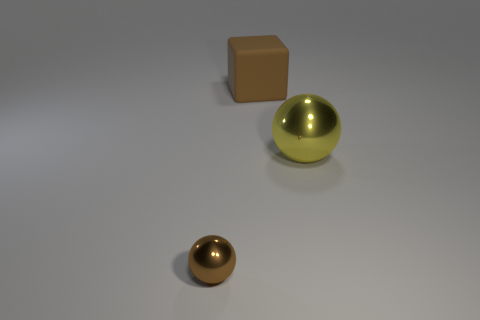Can you tell me about the lighting in the scene? The image exhibits a soft, diffused lighting coming from above. There are soft shadows directly underneath the objects, indicating the light source is not overly harsh. This kind of lighting tends to reveal the textures of the objects with a gentle gradient of light to dark. 